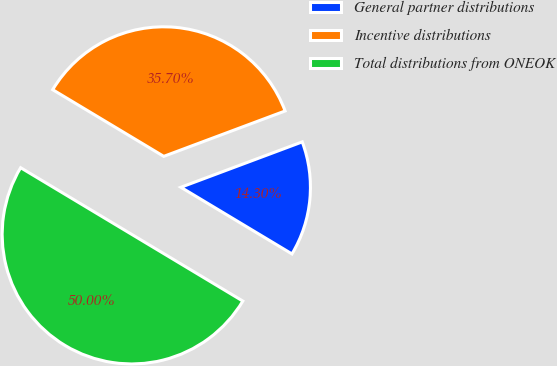<chart> <loc_0><loc_0><loc_500><loc_500><pie_chart><fcel>General partner distributions<fcel>Incentive distributions<fcel>Total distributions from ONEOK<nl><fcel>14.3%<fcel>35.7%<fcel>50.0%<nl></chart> 